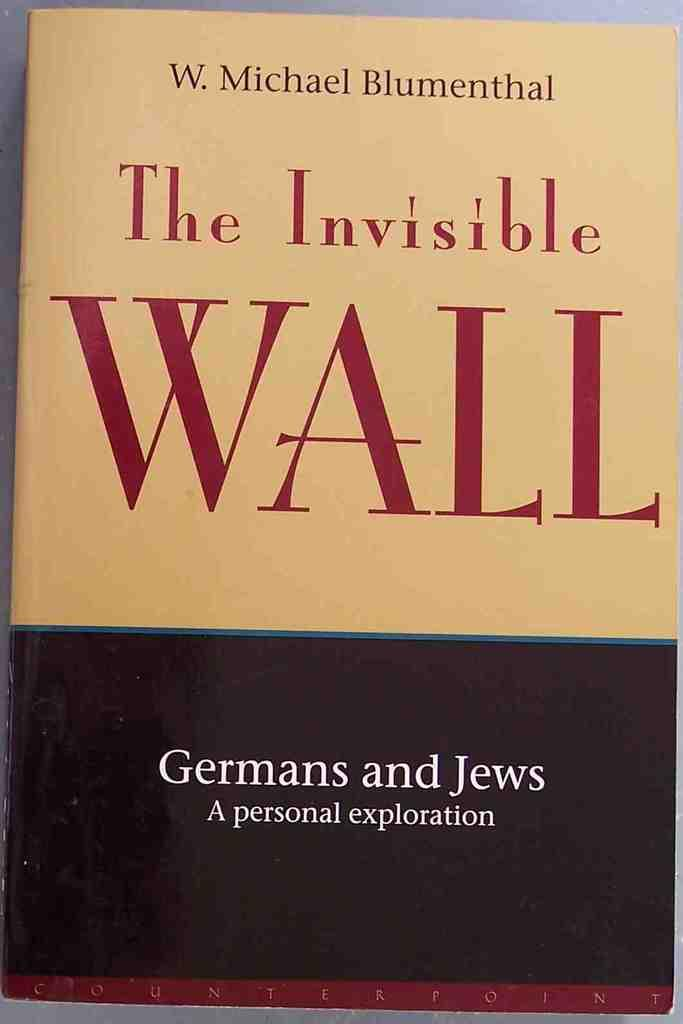Provide a one-sentence caption for the provided image. A book written by Michael Blumenthal titled The Invisible Wall. 